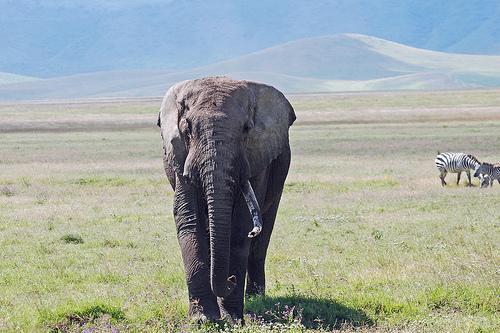How many tusks does the elephant have?
Give a very brief answer. 1. How many mountains are there?
Give a very brief answer. 1. How many elephants are there?
Give a very brief answer. 1. How many ears does the elephant have?
Give a very brief answer. 2. How many zebras are there?
Give a very brief answer. 2. 